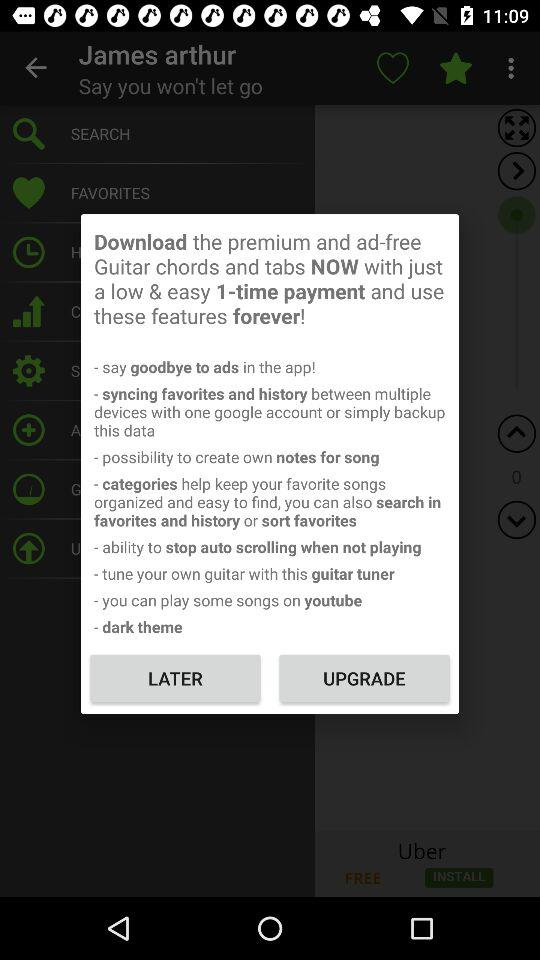How many features are offered in the premium version?
Answer the question using a single word or phrase. 8 